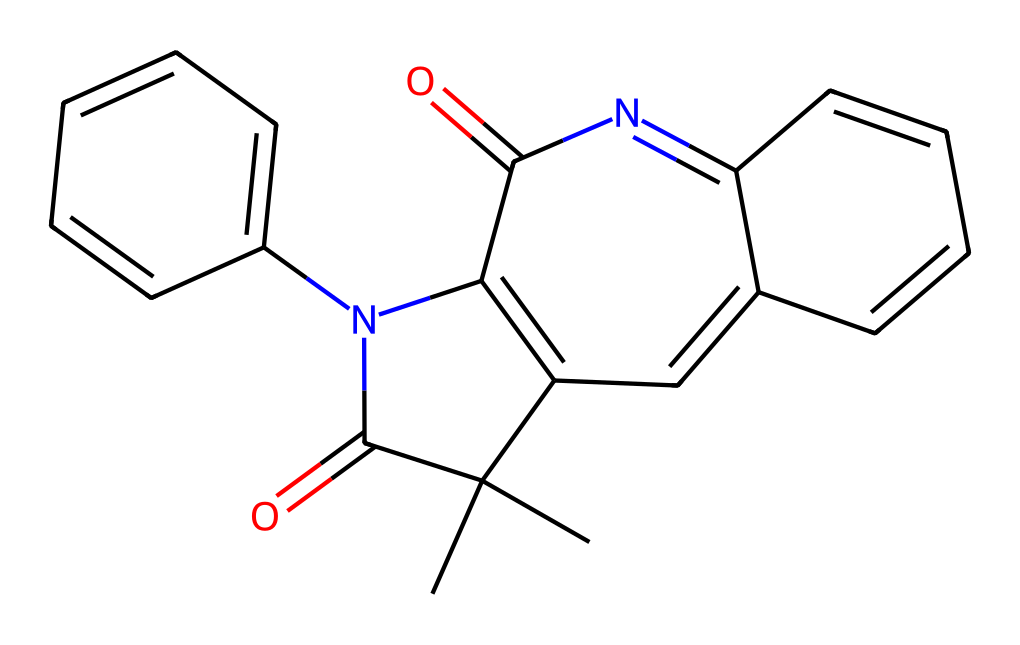How many rings are present in this structure? The structure contains three distinct ring formations, identifiable in the SMILES representation through the indicators such as 'C=CC' and 'C=C'. Each ring is characterized by multiple double bonds connecting carbon atoms.
Answer: three What functional group is present in this compound? The SMILES representation includes 'C(=O)', which indicates the presence of a carbonyl group, typical for ketones or aldehydes. The presence of this group is essential for the reactivity of photoreactive chemicals.
Answer: carbonyl Is there a nitrogen atom present in the structure? By analyzing the SMILES code, we can see 'N(c2ccccc2)', which denotes the presence of a nitrogen atom connected to a benzene ring, confirming that nitrogen is part of the structure.
Answer: yes What type of reaction can this spiropyran compound undergo? The presence of the carbonyl and the ability of the structure to rearrange upon light exposure suggests the compound can undergo isomerization. This is typical for spiropyrans that switch between forms based on light conditions.
Answer: isomerization What is the role of the carbonyl group in smart window applications? The carbonyl group can serve as a photoreactive site that responds to specific wavelengths of light, allowing the smart window to change its optical properties based on light exposure for energy efficiency.
Answer: photoreactivity 